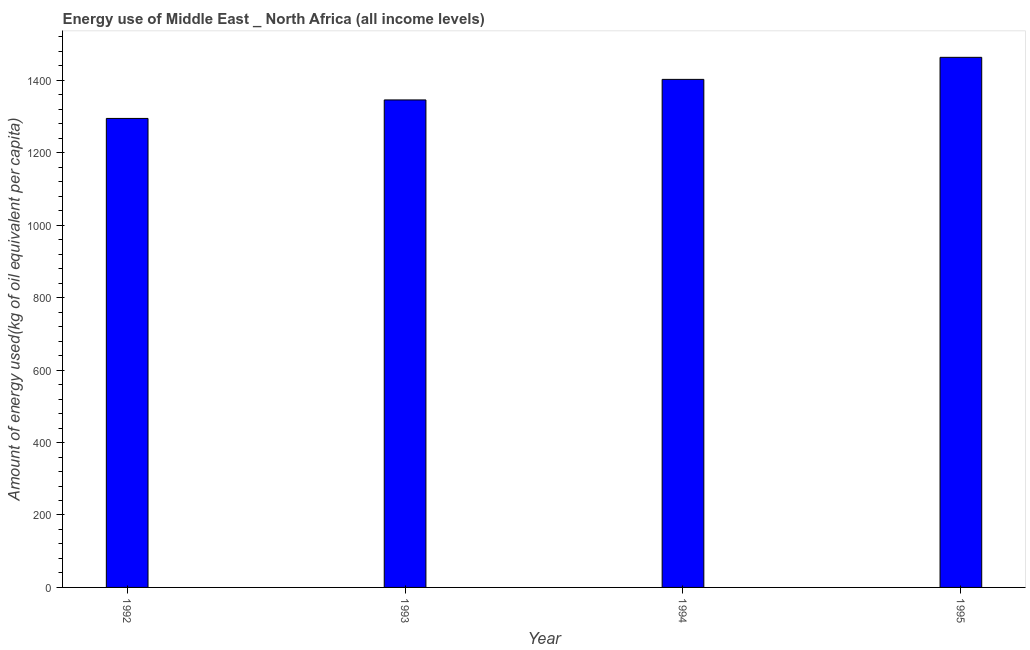Does the graph contain grids?
Give a very brief answer. No. What is the title of the graph?
Your answer should be compact. Energy use of Middle East _ North Africa (all income levels). What is the label or title of the X-axis?
Provide a succinct answer. Year. What is the label or title of the Y-axis?
Give a very brief answer. Amount of energy used(kg of oil equivalent per capita). What is the amount of energy used in 1994?
Ensure brevity in your answer.  1402.93. Across all years, what is the maximum amount of energy used?
Make the answer very short. 1463.82. Across all years, what is the minimum amount of energy used?
Offer a terse response. 1295.09. In which year was the amount of energy used minimum?
Your response must be concise. 1992. What is the sum of the amount of energy used?
Keep it short and to the point. 5508.02. What is the difference between the amount of energy used in 1994 and 1995?
Your answer should be very brief. -60.89. What is the average amount of energy used per year?
Keep it short and to the point. 1377.01. What is the median amount of energy used?
Offer a very short reply. 1374.55. In how many years, is the amount of energy used greater than 960 kg?
Offer a terse response. 4. Do a majority of the years between 1995 and 1994 (inclusive) have amount of energy used greater than 280 kg?
Provide a short and direct response. No. Is the difference between the amount of energy used in 1994 and 1995 greater than the difference between any two years?
Offer a terse response. No. What is the difference between the highest and the second highest amount of energy used?
Your response must be concise. 60.89. Is the sum of the amount of energy used in 1993 and 1995 greater than the maximum amount of energy used across all years?
Your response must be concise. Yes. What is the difference between the highest and the lowest amount of energy used?
Provide a succinct answer. 168.73. How many bars are there?
Ensure brevity in your answer.  4. How many years are there in the graph?
Provide a succinct answer. 4. What is the Amount of energy used(kg of oil equivalent per capita) in 1992?
Provide a succinct answer. 1295.09. What is the Amount of energy used(kg of oil equivalent per capita) of 1993?
Make the answer very short. 1346.17. What is the Amount of energy used(kg of oil equivalent per capita) of 1994?
Offer a terse response. 1402.93. What is the Amount of energy used(kg of oil equivalent per capita) of 1995?
Your answer should be very brief. 1463.82. What is the difference between the Amount of energy used(kg of oil equivalent per capita) in 1992 and 1993?
Keep it short and to the point. -51.08. What is the difference between the Amount of energy used(kg of oil equivalent per capita) in 1992 and 1994?
Your answer should be compact. -107.84. What is the difference between the Amount of energy used(kg of oil equivalent per capita) in 1992 and 1995?
Your answer should be very brief. -168.73. What is the difference between the Amount of energy used(kg of oil equivalent per capita) in 1993 and 1994?
Make the answer very short. -56.76. What is the difference between the Amount of energy used(kg of oil equivalent per capita) in 1993 and 1995?
Offer a very short reply. -117.65. What is the difference between the Amount of energy used(kg of oil equivalent per capita) in 1994 and 1995?
Your answer should be very brief. -60.89. What is the ratio of the Amount of energy used(kg of oil equivalent per capita) in 1992 to that in 1994?
Keep it short and to the point. 0.92. What is the ratio of the Amount of energy used(kg of oil equivalent per capita) in 1992 to that in 1995?
Keep it short and to the point. 0.89. What is the ratio of the Amount of energy used(kg of oil equivalent per capita) in 1993 to that in 1995?
Keep it short and to the point. 0.92. What is the ratio of the Amount of energy used(kg of oil equivalent per capita) in 1994 to that in 1995?
Offer a terse response. 0.96. 